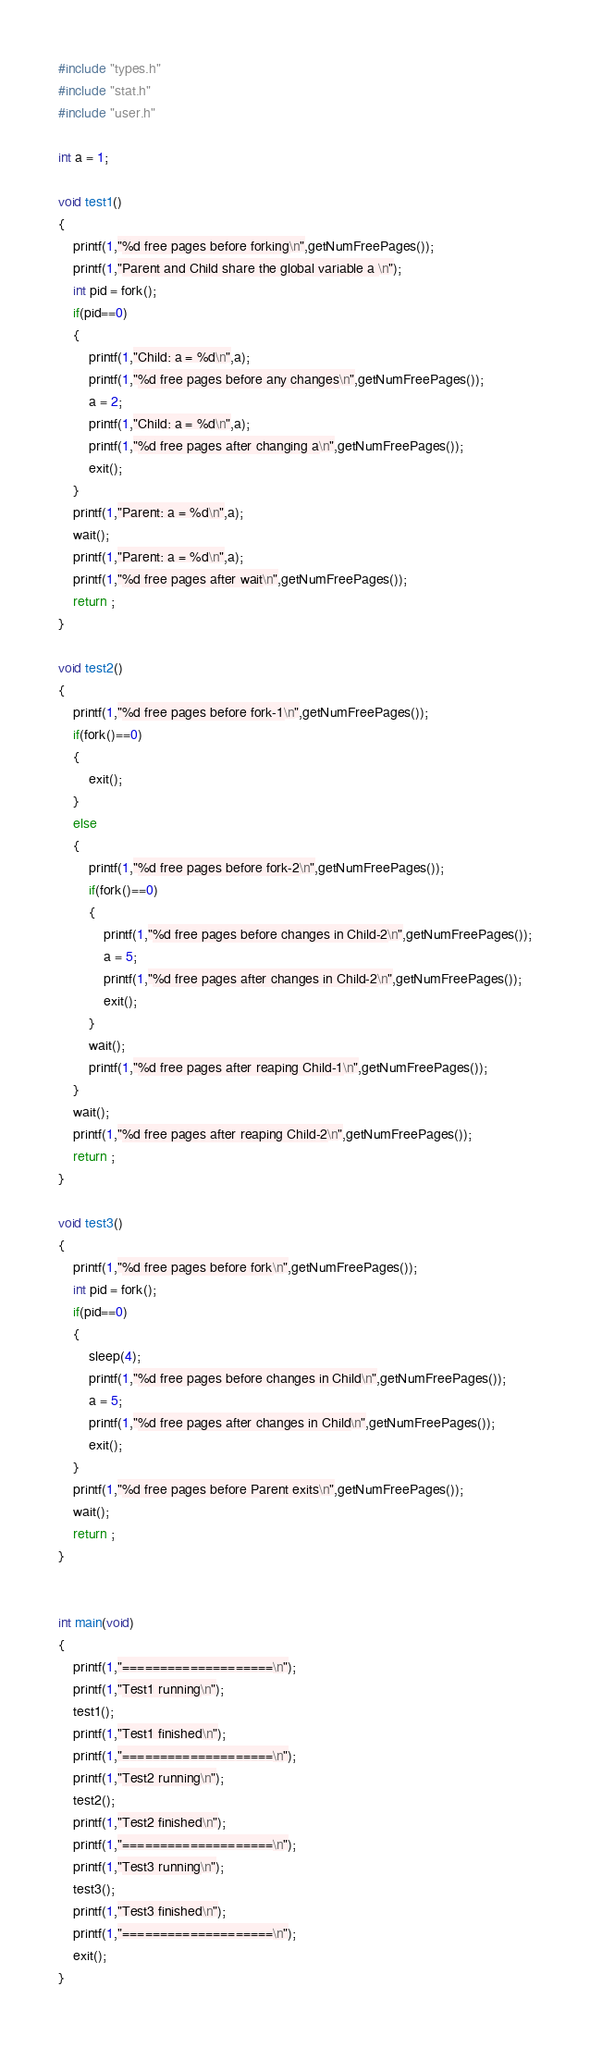<code> <loc_0><loc_0><loc_500><loc_500><_C_>#include "types.h"
#include "stat.h"
#include "user.h"

int a = 1;

void test1()
{
    printf(1,"%d free pages before forking\n",getNumFreePages());
    printf(1,"Parent and Child share the global variable a \n");
    int pid = fork();
    if(pid==0)
    {
        printf(1,"Child: a = %d\n",a);
        printf(1,"%d free pages before any changes\n",getNumFreePages());
        a = 2;
        printf(1,"Child: a = %d\n",a);
        printf(1,"%d free pages after changing a\n",getNumFreePages());
        exit();
    }
    printf(1,"Parent: a = %d\n",a);
    wait();
    printf(1,"Parent: a = %d\n",a);
    printf(1,"%d free pages after wait\n",getNumFreePages());
    return ;
}

void test2()
{
    printf(1,"%d free pages before fork-1\n",getNumFreePages());
    if(fork()==0)
    {
        exit();
    }
    else
    {
        printf(1,"%d free pages before fork-2\n",getNumFreePages());
        if(fork()==0)
        {
            printf(1,"%d free pages before changes in Child-2\n",getNumFreePages());
            a = 5;
            printf(1,"%d free pages after changes in Child-2\n",getNumFreePages());
            exit();
        }
        wait();
        printf(1,"%d free pages after reaping Child-1\n",getNumFreePages());
    }
    wait();
    printf(1,"%d free pages after reaping Child-2\n",getNumFreePages());
    return ;
}

void test3()
{
    printf(1,"%d free pages before fork\n",getNumFreePages());
    int pid = fork();
    if(pid==0)
    {
        sleep(4);
        printf(1,"%d free pages before changes in Child\n",getNumFreePages());
        a = 5;
        printf(1,"%d free pages after changes in Child\n",getNumFreePages());
        exit();
    }
    printf(1,"%d free pages before Parent exits\n",getNumFreePages());
    wait();
    return ;
}


int main(void)
{
    printf(1,"====================\n");
    printf(1,"Test1 running\n");
    test1();
    printf(1,"Test1 finished\n");
    printf(1,"====================\n");
    printf(1,"Test2 running\n");
    test2();
    printf(1,"Test2 finished\n");
    printf(1,"====================\n");
    printf(1,"Test3 running\n");
    test3();
    printf(1,"Test3 finished\n");
    printf(1,"====================\n");
    exit();
}
</code> 